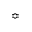Convert formula to latex. <formula><loc_0><loc_0><loc_500><loc_500>\ B u m p e q</formula> 